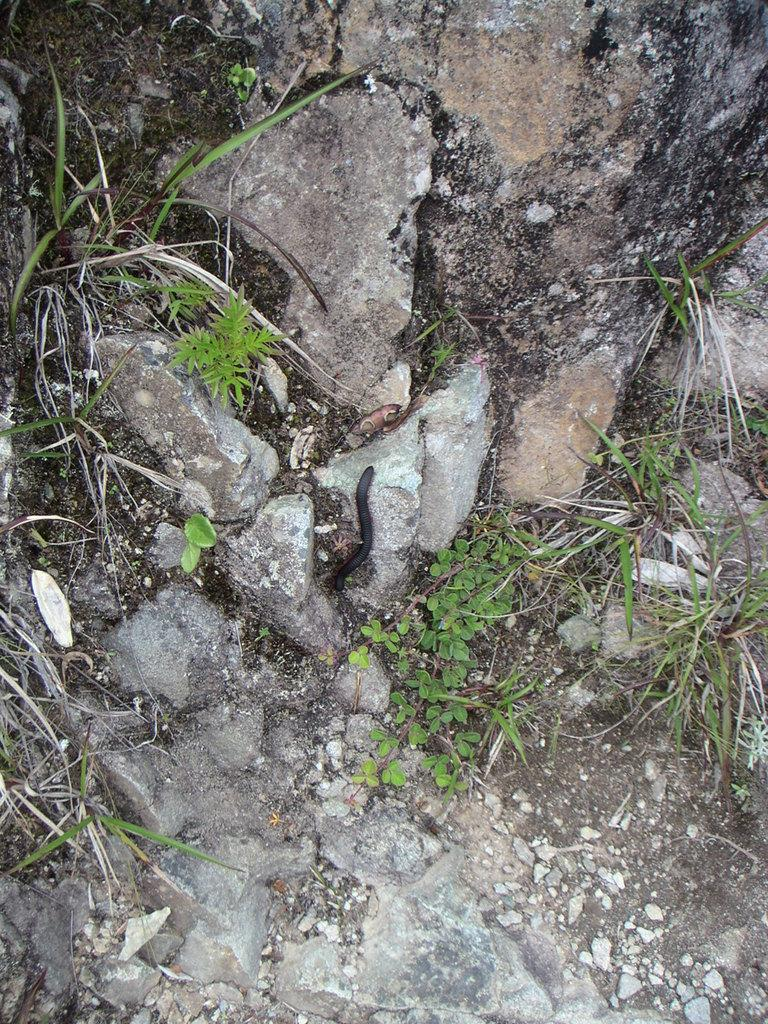What type of creature can be seen in the image? There is an insect in the image. What type of natural elements are present in the image? There are rocks and grass in the image. What type of fruit is hanging from the tree in the image? There is no tree or fruit present in the image; it features an insect and natural elements like rocks and grass. 